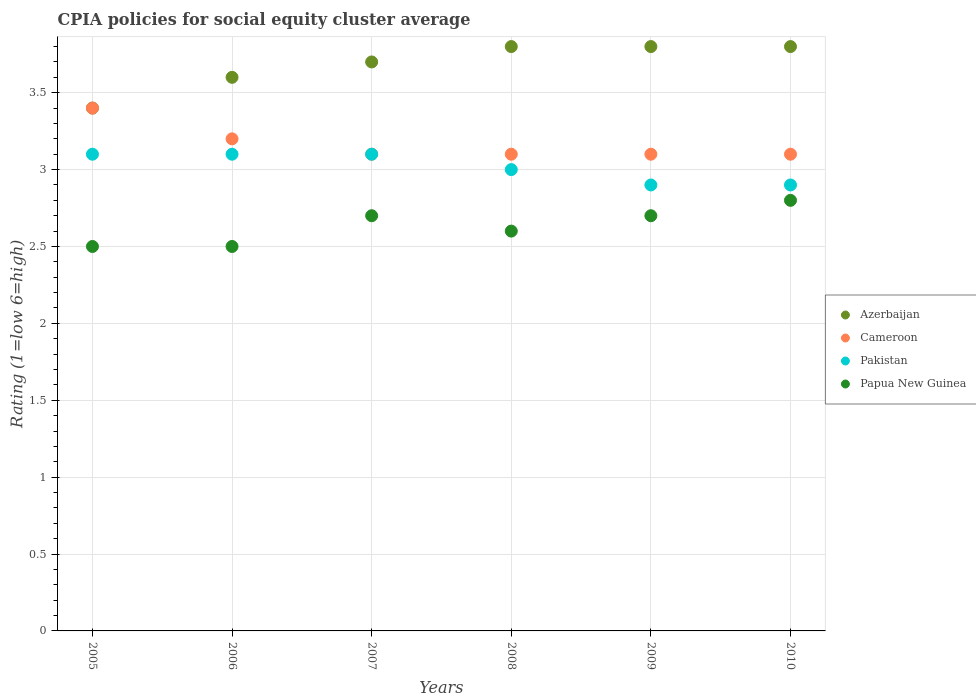Across all years, what is the maximum CPIA rating in Pakistan?
Provide a short and direct response. 3.1. Across all years, what is the minimum CPIA rating in Cameroon?
Give a very brief answer. 3.1. In which year was the CPIA rating in Cameroon minimum?
Offer a very short reply. 2007. What is the difference between the CPIA rating in Papua New Guinea in 2005 and that in 2007?
Your answer should be very brief. -0.2. What is the difference between the CPIA rating in Papua New Guinea in 2006 and the CPIA rating in Pakistan in 2009?
Provide a short and direct response. -0.4. What is the average CPIA rating in Azerbaijan per year?
Offer a terse response. 3.68. In the year 2008, what is the difference between the CPIA rating in Papua New Guinea and CPIA rating in Azerbaijan?
Provide a short and direct response. -1.2. In how many years, is the CPIA rating in Cameroon greater than 3.2?
Provide a short and direct response. 1. What is the ratio of the CPIA rating in Papua New Guinea in 2007 to that in 2010?
Provide a succinct answer. 0.96. Is the CPIA rating in Azerbaijan in 2006 less than that in 2010?
Keep it short and to the point. Yes. What is the difference between the highest and the lowest CPIA rating in Azerbaijan?
Give a very brief answer. 0.4. Is the CPIA rating in Azerbaijan strictly greater than the CPIA rating in Cameroon over the years?
Offer a terse response. No. Is the CPIA rating in Cameroon strictly less than the CPIA rating in Papua New Guinea over the years?
Give a very brief answer. No. How many years are there in the graph?
Provide a short and direct response. 6. Where does the legend appear in the graph?
Your response must be concise. Center right. What is the title of the graph?
Your response must be concise. CPIA policies for social equity cluster average. What is the label or title of the X-axis?
Your response must be concise. Years. What is the label or title of the Y-axis?
Offer a very short reply. Rating (1=low 6=high). What is the Rating (1=low 6=high) in Cameroon in 2006?
Your response must be concise. 3.2. What is the Rating (1=low 6=high) of Pakistan in 2006?
Your response must be concise. 3.1. What is the Rating (1=low 6=high) of Papua New Guinea in 2006?
Your answer should be compact. 2.5. What is the Rating (1=low 6=high) in Cameroon in 2007?
Provide a short and direct response. 3.1. What is the Rating (1=low 6=high) of Papua New Guinea in 2007?
Offer a terse response. 2.7. What is the Rating (1=low 6=high) in Azerbaijan in 2008?
Your answer should be compact. 3.8. What is the Rating (1=low 6=high) in Cameroon in 2008?
Give a very brief answer. 3.1. What is the Rating (1=low 6=high) in Pakistan in 2008?
Offer a very short reply. 3. What is the Rating (1=low 6=high) of Papua New Guinea in 2008?
Your answer should be compact. 2.6. What is the Rating (1=low 6=high) in Papua New Guinea in 2009?
Provide a short and direct response. 2.7. What is the Rating (1=low 6=high) of Papua New Guinea in 2010?
Provide a succinct answer. 2.8. Across all years, what is the maximum Rating (1=low 6=high) of Papua New Guinea?
Provide a succinct answer. 2.8. Across all years, what is the minimum Rating (1=low 6=high) of Azerbaijan?
Provide a short and direct response. 3.4. Across all years, what is the minimum Rating (1=low 6=high) in Cameroon?
Your response must be concise. 3.1. Across all years, what is the minimum Rating (1=low 6=high) in Pakistan?
Provide a short and direct response. 2.9. What is the total Rating (1=low 6=high) of Azerbaijan in the graph?
Your response must be concise. 22.1. What is the total Rating (1=low 6=high) of Pakistan in the graph?
Your response must be concise. 18.1. What is the difference between the Rating (1=low 6=high) of Azerbaijan in 2005 and that in 2006?
Ensure brevity in your answer.  -0.2. What is the difference between the Rating (1=low 6=high) of Papua New Guinea in 2005 and that in 2006?
Give a very brief answer. 0. What is the difference between the Rating (1=low 6=high) in Azerbaijan in 2005 and that in 2007?
Your response must be concise. -0.3. What is the difference between the Rating (1=low 6=high) in Papua New Guinea in 2005 and that in 2007?
Offer a terse response. -0.2. What is the difference between the Rating (1=low 6=high) of Azerbaijan in 2005 and that in 2008?
Offer a very short reply. -0.4. What is the difference between the Rating (1=low 6=high) in Azerbaijan in 2005 and that in 2009?
Provide a succinct answer. -0.4. What is the difference between the Rating (1=low 6=high) of Cameroon in 2005 and that in 2009?
Provide a succinct answer. 0.3. What is the difference between the Rating (1=low 6=high) in Pakistan in 2005 and that in 2009?
Provide a short and direct response. 0.2. What is the difference between the Rating (1=low 6=high) in Cameroon in 2005 and that in 2010?
Your response must be concise. 0.3. What is the difference between the Rating (1=low 6=high) of Azerbaijan in 2006 and that in 2007?
Offer a terse response. -0.1. What is the difference between the Rating (1=low 6=high) of Papua New Guinea in 2006 and that in 2007?
Your response must be concise. -0.2. What is the difference between the Rating (1=low 6=high) in Papua New Guinea in 2006 and that in 2008?
Your answer should be very brief. -0.1. What is the difference between the Rating (1=low 6=high) in Azerbaijan in 2006 and that in 2009?
Offer a terse response. -0.2. What is the difference between the Rating (1=low 6=high) of Cameroon in 2006 and that in 2009?
Your response must be concise. 0.1. What is the difference between the Rating (1=low 6=high) of Pakistan in 2006 and that in 2009?
Keep it short and to the point. 0.2. What is the difference between the Rating (1=low 6=high) of Azerbaijan in 2006 and that in 2010?
Make the answer very short. -0.2. What is the difference between the Rating (1=low 6=high) in Cameroon in 2006 and that in 2010?
Offer a very short reply. 0.1. What is the difference between the Rating (1=low 6=high) in Cameroon in 2007 and that in 2008?
Give a very brief answer. 0. What is the difference between the Rating (1=low 6=high) of Papua New Guinea in 2007 and that in 2008?
Offer a terse response. 0.1. What is the difference between the Rating (1=low 6=high) in Cameroon in 2007 and that in 2009?
Ensure brevity in your answer.  0. What is the difference between the Rating (1=low 6=high) in Pakistan in 2007 and that in 2009?
Offer a very short reply. 0.2. What is the difference between the Rating (1=low 6=high) in Pakistan in 2008 and that in 2009?
Provide a succinct answer. 0.1. What is the difference between the Rating (1=low 6=high) in Papua New Guinea in 2008 and that in 2009?
Ensure brevity in your answer.  -0.1. What is the difference between the Rating (1=low 6=high) in Papua New Guinea in 2008 and that in 2010?
Ensure brevity in your answer.  -0.2. What is the difference between the Rating (1=low 6=high) of Cameroon in 2009 and that in 2010?
Provide a succinct answer. 0. What is the difference between the Rating (1=low 6=high) of Pakistan in 2009 and that in 2010?
Your answer should be very brief. 0. What is the difference between the Rating (1=low 6=high) of Azerbaijan in 2005 and the Rating (1=low 6=high) of Papua New Guinea in 2006?
Provide a short and direct response. 0.9. What is the difference between the Rating (1=low 6=high) in Pakistan in 2005 and the Rating (1=low 6=high) in Papua New Guinea in 2006?
Make the answer very short. 0.6. What is the difference between the Rating (1=low 6=high) in Azerbaijan in 2005 and the Rating (1=low 6=high) in Cameroon in 2007?
Offer a terse response. 0.3. What is the difference between the Rating (1=low 6=high) of Azerbaijan in 2005 and the Rating (1=low 6=high) of Pakistan in 2007?
Your response must be concise. 0.3. What is the difference between the Rating (1=low 6=high) of Azerbaijan in 2005 and the Rating (1=low 6=high) of Papua New Guinea in 2007?
Your answer should be very brief. 0.7. What is the difference between the Rating (1=low 6=high) of Cameroon in 2005 and the Rating (1=low 6=high) of Pakistan in 2007?
Make the answer very short. 0.3. What is the difference between the Rating (1=low 6=high) of Azerbaijan in 2005 and the Rating (1=low 6=high) of Cameroon in 2008?
Your answer should be compact. 0.3. What is the difference between the Rating (1=low 6=high) of Cameroon in 2005 and the Rating (1=low 6=high) of Pakistan in 2008?
Your answer should be very brief. 0.4. What is the difference between the Rating (1=low 6=high) of Cameroon in 2005 and the Rating (1=low 6=high) of Papua New Guinea in 2008?
Give a very brief answer. 0.8. What is the difference between the Rating (1=low 6=high) in Azerbaijan in 2005 and the Rating (1=low 6=high) in Cameroon in 2009?
Your response must be concise. 0.3. What is the difference between the Rating (1=low 6=high) of Azerbaijan in 2005 and the Rating (1=low 6=high) of Papua New Guinea in 2009?
Your answer should be very brief. 0.7. What is the difference between the Rating (1=low 6=high) in Cameroon in 2005 and the Rating (1=low 6=high) in Pakistan in 2009?
Your response must be concise. 0.5. What is the difference between the Rating (1=low 6=high) of Cameroon in 2005 and the Rating (1=low 6=high) of Papua New Guinea in 2009?
Ensure brevity in your answer.  0.7. What is the difference between the Rating (1=low 6=high) in Azerbaijan in 2005 and the Rating (1=low 6=high) in Papua New Guinea in 2010?
Your answer should be compact. 0.6. What is the difference between the Rating (1=low 6=high) in Cameroon in 2005 and the Rating (1=low 6=high) in Pakistan in 2010?
Your response must be concise. 0.5. What is the difference between the Rating (1=low 6=high) of Azerbaijan in 2006 and the Rating (1=low 6=high) of Cameroon in 2007?
Offer a very short reply. 0.5. What is the difference between the Rating (1=low 6=high) of Cameroon in 2006 and the Rating (1=low 6=high) of Pakistan in 2007?
Provide a succinct answer. 0.1. What is the difference between the Rating (1=low 6=high) of Cameroon in 2006 and the Rating (1=low 6=high) of Papua New Guinea in 2007?
Your answer should be compact. 0.5. What is the difference between the Rating (1=low 6=high) of Azerbaijan in 2006 and the Rating (1=low 6=high) of Pakistan in 2008?
Offer a terse response. 0.6. What is the difference between the Rating (1=low 6=high) of Azerbaijan in 2006 and the Rating (1=low 6=high) of Papua New Guinea in 2008?
Keep it short and to the point. 1. What is the difference between the Rating (1=low 6=high) of Cameroon in 2006 and the Rating (1=low 6=high) of Papua New Guinea in 2008?
Offer a very short reply. 0.6. What is the difference between the Rating (1=low 6=high) of Azerbaijan in 2006 and the Rating (1=low 6=high) of Cameroon in 2009?
Your answer should be compact. 0.5. What is the difference between the Rating (1=low 6=high) in Azerbaijan in 2006 and the Rating (1=low 6=high) in Pakistan in 2009?
Your answer should be compact. 0.7. What is the difference between the Rating (1=low 6=high) of Cameroon in 2006 and the Rating (1=low 6=high) of Papua New Guinea in 2009?
Ensure brevity in your answer.  0.5. What is the difference between the Rating (1=low 6=high) of Cameroon in 2006 and the Rating (1=low 6=high) of Pakistan in 2010?
Make the answer very short. 0.3. What is the difference between the Rating (1=low 6=high) of Pakistan in 2006 and the Rating (1=low 6=high) of Papua New Guinea in 2010?
Your answer should be compact. 0.3. What is the difference between the Rating (1=low 6=high) of Azerbaijan in 2007 and the Rating (1=low 6=high) of Cameroon in 2008?
Your response must be concise. 0.6. What is the difference between the Rating (1=low 6=high) of Azerbaijan in 2007 and the Rating (1=low 6=high) of Pakistan in 2008?
Your answer should be compact. 0.7. What is the difference between the Rating (1=low 6=high) in Cameroon in 2007 and the Rating (1=low 6=high) in Pakistan in 2008?
Offer a terse response. 0.1. What is the difference between the Rating (1=low 6=high) in Cameroon in 2007 and the Rating (1=low 6=high) in Papua New Guinea in 2008?
Your answer should be compact. 0.5. What is the difference between the Rating (1=low 6=high) of Azerbaijan in 2007 and the Rating (1=low 6=high) of Cameroon in 2009?
Keep it short and to the point. 0.6. What is the difference between the Rating (1=low 6=high) of Azerbaijan in 2007 and the Rating (1=low 6=high) of Pakistan in 2009?
Keep it short and to the point. 0.8. What is the difference between the Rating (1=low 6=high) of Azerbaijan in 2007 and the Rating (1=low 6=high) of Papua New Guinea in 2009?
Provide a short and direct response. 1. What is the difference between the Rating (1=low 6=high) of Cameroon in 2007 and the Rating (1=low 6=high) of Papua New Guinea in 2009?
Your answer should be very brief. 0.4. What is the difference between the Rating (1=low 6=high) in Pakistan in 2007 and the Rating (1=low 6=high) in Papua New Guinea in 2009?
Offer a very short reply. 0.4. What is the difference between the Rating (1=low 6=high) in Azerbaijan in 2007 and the Rating (1=low 6=high) in Cameroon in 2010?
Your answer should be compact. 0.6. What is the difference between the Rating (1=low 6=high) of Azerbaijan in 2007 and the Rating (1=low 6=high) of Papua New Guinea in 2010?
Offer a very short reply. 0.9. What is the difference between the Rating (1=low 6=high) in Cameroon in 2007 and the Rating (1=low 6=high) in Pakistan in 2010?
Give a very brief answer. 0.2. What is the difference between the Rating (1=low 6=high) in Cameroon in 2007 and the Rating (1=low 6=high) in Papua New Guinea in 2010?
Offer a very short reply. 0.3. What is the difference between the Rating (1=low 6=high) in Pakistan in 2007 and the Rating (1=low 6=high) in Papua New Guinea in 2010?
Keep it short and to the point. 0.3. What is the difference between the Rating (1=low 6=high) in Azerbaijan in 2008 and the Rating (1=low 6=high) in Cameroon in 2009?
Provide a short and direct response. 0.7. What is the difference between the Rating (1=low 6=high) in Azerbaijan in 2008 and the Rating (1=low 6=high) in Pakistan in 2009?
Make the answer very short. 0.9. What is the difference between the Rating (1=low 6=high) of Azerbaijan in 2008 and the Rating (1=low 6=high) of Papua New Guinea in 2009?
Your answer should be very brief. 1.1. What is the difference between the Rating (1=low 6=high) in Cameroon in 2008 and the Rating (1=low 6=high) in Papua New Guinea in 2009?
Provide a succinct answer. 0.4. What is the difference between the Rating (1=low 6=high) in Azerbaijan in 2008 and the Rating (1=low 6=high) in Cameroon in 2010?
Provide a succinct answer. 0.7. What is the difference between the Rating (1=low 6=high) in Azerbaijan in 2008 and the Rating (1=low 6=high) in Pakistan in 2010?
Offer a terse response. 0.9. What is the difference between the Rating (1=low 6=high) of Azerbaijan in 2008 and the Rating (1=low 6=high) of Papua New Guinea in 2010?
Provide a succinct answer. 1. What is the difference between the Rating (1=low 6=high) in Pakistan in 2008 and the Rating (1=low 6=high) in Papua New Guinea in 2010?
Ensure brevity in your answer.  0.2. What is the difference between the Rating (1=low 6=high) of Azerbaijan in 2009 and the Rating (1=low 6=high) of Cameroon in 2010?
Offer a very short reply. 0.7. What is the difference between the Rating (1=low 6=high) of Azerbaijan in 2009 and the Rating (1=low 6=high) of Papua New Guinea in 2010?
Provide a short and direct response. 1. What is the difference between the Rating (1=low 6=high) of Cameroon in 2009 and the Rating (1=low 6=high) of Pakistan in 2010?
Keep it short and to the point. 0.2. What is the average Rating (1=low 6=high) of Azerbaijan per year?
Keep it short and to the point. 3.68. What is the average Rating (1=low 6=high) of Cameroon per year?
Keep it short and to the point. 3.17. What is the average Rating (1=low 6=high) in Pakistan per year?
Offer a very short reply. 3.02. What is the average Rating (1=low 6=high) of Papua New Guinea per year?
Give a very brief answer. 2.63. In the year 2006, what is the difference between the Rating (1=low 6=high) of Cameroon and Rating (1=low 6=high) of Pakistan?
Your response must be concise. 0.1. In the year 2006, what is the difference between the Rating (1=low 6=high) in Cameroon and Rating (1=low 6=high) in Papua New Guinea?
Give a very brief answer. 0.7. In the year 2006, what is the difference between the Rating (1=low 6=high) of Pakistan and Rating (1=low 6=high) of Papua New Guinea?
Ensure brevity in your answer.  0.6. In the year 2007, what is the difference between the Rating (1=low 6=high) in Azerbaijan and Rating (1=low 6=high) in Cameroon?
Ensure brevity in your answer.  0.6. In the year 2007, what is the difference between the Rating (1=low 6=high) of Azerbaijan and Rating (1=low 6=high) of Papua New Guinea?
Ensure brevity in your answer.  1. In the year 2007, what is the difference between the Rating (1=low 6=high) in Pakistan and Rating (1=low 6=high) in Papua New Guinea?
Your answer should be compact. 0.4. In the year 2008, what is the difference between the Rating (1=low 6=high) in Azerbaijan and Rating (1=low 6=high) in Papua New Guinea?
Keep it short and to the point. 1.2. In the year 2008, what is the difference between the Rating (1=low 6=high) in Cameroon and Rating (1=low 6=high) in Pakistan?
Your answer should be compact. 0.1. In the year 2008, what is the difference between the Rating (1=low 6=high) in Cameroon and Rating (1=low 6=high) in Papua New Guinea?
Your answer should be compact. 0.5. In the year 2009, what is the difference between the Rating (1=low 6=high) of Azerbaijan and Rating (1=low 6=high) of Papua New Guinea?
Keep it short and to the point. 1.1. In the year 2009, what is the difference between the Rating (1=low 6=high) of Cameroon and Rating (1=low 6=high) of Pakistan?
Ensure brevity in your answer.  0.2. In the year 2009, what is the difference between the Rating (1=low 6=high) in Cameroon and Rating (1=low 6=high) in Papua New Guinea?
Your response must be concise. 0.4. In the year 2009, what is the difference between the Rating (1=low 6=high) in Pakistan and Rating (1=low 6=high) in Papua New Guinea?
Provide a short and direct response. 0.2. In the year 2010, what is the difference between the Rating (1=low 6=high) in Azerbaijan and Rating (1=low 6=high) in Pakistan?
Your answer should be very brief. 0.9. In the year 2010, what is the difference between the Rating (1=low 6=high) of Azerbaijan and Rating (1=low 6=high) of Papua New Guinea?
Make the answer very short. 1. In the year 2010, what is the difference between the Rating (1=low 6=high) of Cameroon and Rating (1=low 6=high) of Pakistan?
Your answer should be compact. 0.2. In the year 2010, what is the difference between the Rating (1=low 6=high) in Pakistan and Rating (1=low 6=high) in Papua New Guinea?
Give a very brief answer. 0.1. What is the ratio of the Rating (1=low 6=high) in Azerbaijan in 2005 to that in 2006?
Your answer should be very brief. 0.94. What is the ratio of the Rating (1=low 6=high) of Cameroon in 2005 to that in 2006?
Ensure brevity in your answer.  1.06. What is the ratio of the Rating (1=low 6=high) of Papua New Guinea in 2005 to that in 2006?
Give a very brief answer. 1. What is the ratio of the Rating (1=low 6=high) of Azerbaijan in 2005 to that in 2007?
Your answer should be very brief. 0.92. What is the ratio of the Rating (1=low 6=high) of Cameroon in 2005 to that in 2007?
Your answer should be very brief. 1.1. What is the ratio of the Rating (1=low 6=high) of Papua New Guinea in 2005 to that in 2007?
Offer a very short reply. 0.93. What is the ratio of the Rating (1=low 6=high) of Azerbaijan in 2005 to that in 2008?
Offer a very short reply. 0.89. What is the ratio of the Rating (1=low 6=high) of Cameroon in 2005 to that in 2008?
Your answer should be very brief. 1.1. What is the ratio of the Rating (1=low 6=high) of Pakistan in 2005 to that in 2008?
Your answer should be compact. 1.03. What is the ratio of the Rating (1=low 6=high) in Papua New Guinea in 2005 to that in 2008?
Offer a very short reply. 0.96. What is the ratio of the Rating (1=low 6=high) of Azerbaijan in 2005 to that in 2009?
Offer a terse response. 0.89. What is the ratio of the Rating (1=low 6=high) in Cameroon in 2005 to that in 2009?
Your answer should be compact. 1.1. What is the ratio of the Rating (1=low 6=high) in Pakistan in 2005 to that in 2009?
Your response must be concise. 1.07. What is the ratio of the Rating (1=low 6=high) of Papua New Guinea in 2005 to that in 2009?
Offer a terse response. 0.93. What is the ratio of the Rating (1=low 6=high) of Azerbaijan in 2005 to that in 2010?
Your answer should be very brief. 0.89. What is the ratio of the Rating (1=low 6=high) of Cameroon in 2005 to that in 2010?
Provide a short and direct response. 1.1. What is the ratio of the Rating (1=low 6=high) of Pakistan in 2005 to that in 2010?
Offer a very short reply. 1.07. What is the ratio of the Rating (1=low 6=high) in Papua New Guinea in 2005 to that in 2010?
Ensure brevity in your answer.  0.89. What is the ratio of the Rating (1=low 6=high) of Cameroon in 2006 to that in 2007?
Provide a short and direct response. 1.03. What is the ratio of the Rating (1=low 6=high) of Papua New Guinea in 2006 to that in 2007?
Provide a succinct answer. 0.93. What is the ratio of the Rating (1=low 6=high) of Azerbaijan in 2006 to that in 2008?
Give a very brief answer. 0.95. What is the ratio of the Rating (1=low 6=high) of Cameroon in 2006 to that in 2008?
Your response must be concise. 1.03. What is the ratio of the Rating (1=low 6=high) in Pakistan in 2006 to that in 2008?
Your answer should be compact. 1.03. What is the ratio of the Rating (1=low 6=high) in Papua New Guinea in 2006 to that in 2008?
Provide a short and direct response. 0.96. What is the ratio of the Rating (1=low 6=high) of Cameroon in 2006 to that in 2009?
Your answer should be compact. 1.03. What is the ratio of the Rating (1=low 6=high) of Pakistan in 2006 to that in 2009?
Offer a terse response. 1.07. What is the ratio of the Rating (1=low 6=high) of Papua New Guinea in 2006 to that in 2009?
Ensure brevity in your answer.  0.93. What is the ratio of the Rating (1=low 6=high) of Azerbaijan in 2006 to that in 2010?
Ensure brevity in your answer.  0.95. What is the ratio of the Rating (1=low 6=high) in Cameroon in 2006 to that in 2010?
Provide a succinct answer. 1.03. What is the ratio of the Rating (1=low 6=high) of Pakistan in 2006 to that in 2010?
Make the answer very short. 1.07. What is the ratio of the Rating (1=low 6=high) in Papua New Guinea in 2006 to that in 2010?
Your answer should be very brief. 0.89. What is the ratio of the Rating (1=low 6=high) of Azerbaijan in 2007 to that in 2008?
Offer a very short reply. 0.97. What is the ratio of the Rating (1=low 6=high) of Azerbaijan in 2007 to that in 2009?
Offer a very short reply. 0.97. What is the ratio of the Rating (1=low 6=high) in Pakistan in 2007 to that in 2009?
Provide a succinct answer. 1.07. What is the ratio of the Rating (1=low 6=high) of Papua New Guinea in 2007 to that in 2009?
Your answer should be compact. 1. What is the ratio of the Rating (1=low 6=high) in Azerbaijan in 2007 to that in 2010?
Offer a terse response. 0.97. What is the ratio of the Rating (1=low 6=high) of Pakistan in 2007 to that in 2010?
Your answer should be compact. 1.07. What is the ratio of the Rating (1=low 6=high) in Pakistan in 2008 to that in 2009?
Keep it short and to the point. 1.03. What is the ratio of the Rating (1=low 6=high) in Papua New Guinea in 2008 to that in 2009?
Your answer should be very brief. 0.96. What is the ratio of the Rating (1=low 6=high) of Pakistan in 2008 to that in 2010?
Make the answer very short. 1.03. What is the ratio of the Rating (1=low 6=high) of Papua New Guinea in 2008 to that in 2010?
Your response must be concise. 0.93. What is the ratio of the Rating (1=low 6=high) in Azerbaijan in 2009 to that in 2010?
Ensure brevity in your answer.  1. What is the ratio of the Rating (1=low 6=high) of Cameroon in 2009 to that in 2010?
Provide a short and direct response. 1. What is the ratio of the Rating (1=low 6=high) in Pakistan in 2009 to that in 2010?
Offer a very short reply. 1. What is the ratio of the Rating (1=low 6=high) in Papua New Guinea in 2009 to that in 2010?
Provide a succinct answer. 0.96. What is the difference between the highest and the second highest Rating (1=low 6=high) in Azerbaijan?
Give a very brief answer. 0. What is the difference between the highest and the second highest Rating (1=low 6=high) of Cameroon?
Give a very brief answer. 0.2. 